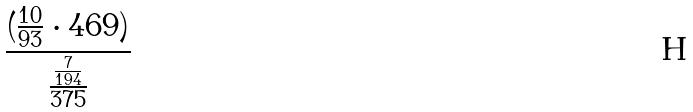<formula> <loc_0><loc_0><loc_500><loc_500>\frac { ( \frac { 1 0 } { 9 3 } \cdot 4 6 9 ) } { \frac { \frac { 7 } { 1 9 4 } } { 3 7 5 } }</formula> 